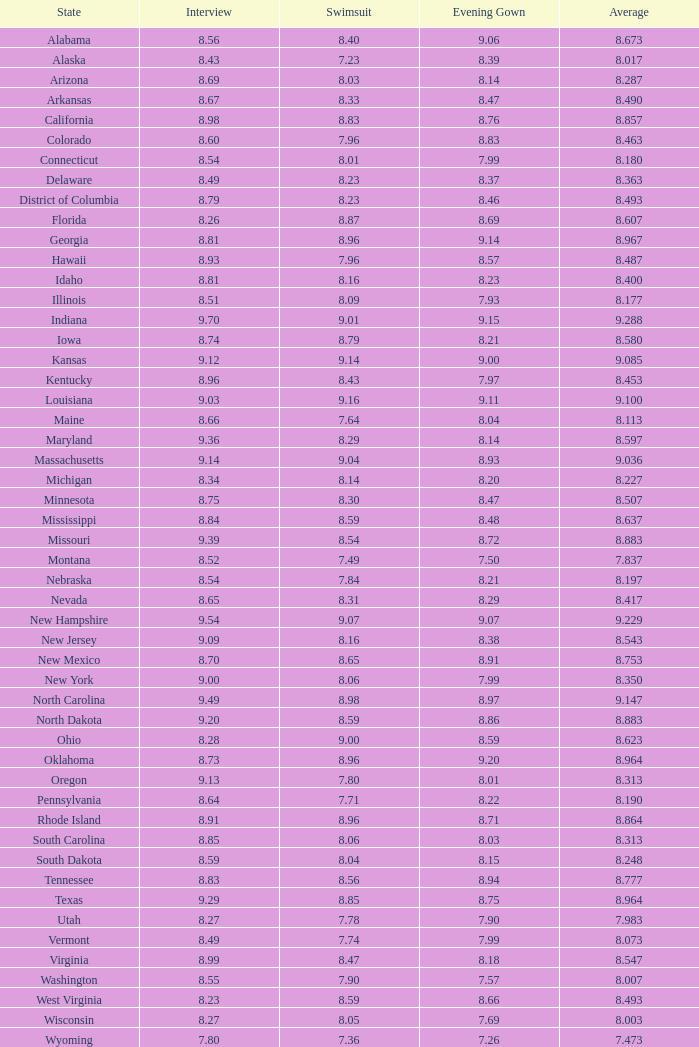Name the total number of swimsuits for evening gowns less than 8.21 and average of 8.453 with interview less than 9.09 1.0. 